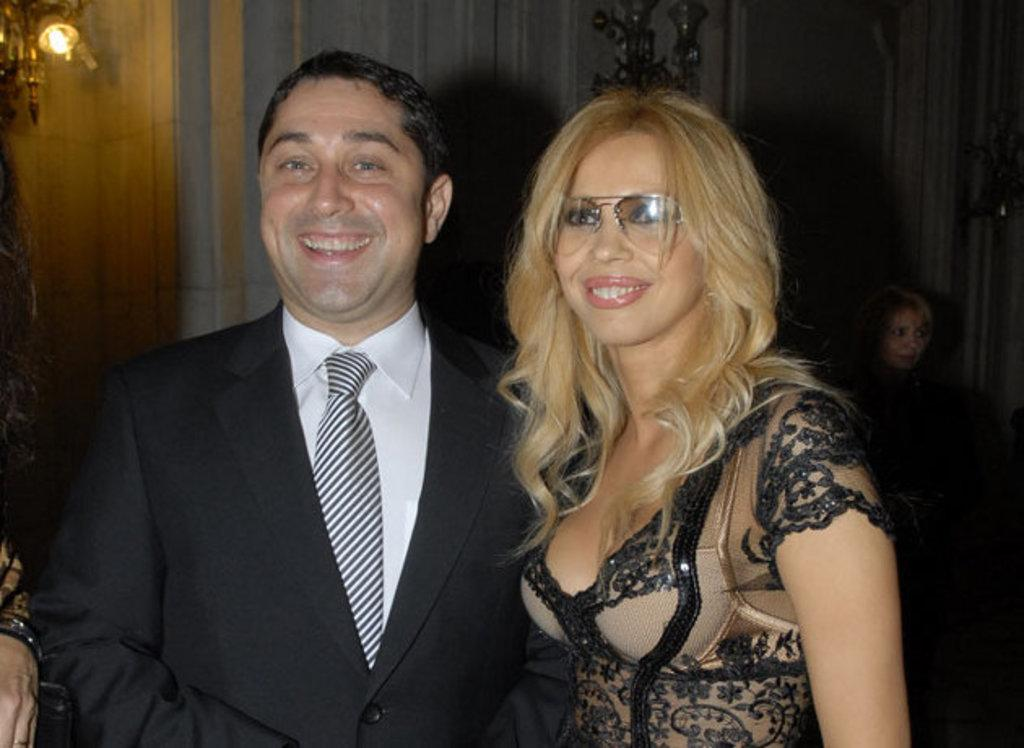How many people are present in the image? There are three people in the image: a man and two women. Can you describe the position of the people in the image? There is a man standing in the image, and there are two women, one standing next to him and another on the right side of the image. What can be seen in the background of the image? There are ceiling lights visible on a wall in the background of the image. What type of grass is growing on the ceiling in the image? There is no grass present in the image, and the ceiling lights are not related to grass. 